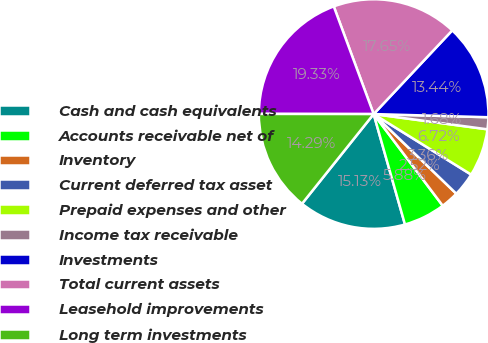Convert chart. <chart><loc_0><loc_0><loc_500><loc_500><pie_chart><fcel>Cash and cash equivalents<fcel>Accounts receivable net of<fcel>Inventory<fcel>Current deferred tax asset<fcel>Prepaid expenses and other<fcel>Income tax receivable<fcel>Investments<fcel>Total current assets<fcel>Leasehold improvements<fcel>Long term investments<nl><fcel>15.13%<fcel>5.88%<fcel>2.52%<fcel>3.36%<fcel>6.72%<fcel>1.68%<fcel>13.44%<fcel>17.65%<fcel>19.33%<fcel>14.29%<nl></chart> 